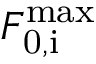Convert formula to latex. <formula><loc_0><loc_0><loc_500><loc_500>F _ { 0 , i } ^ { \max }</formula> 